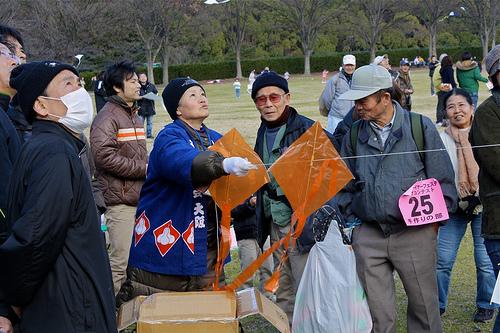Have they already had drinks?
Short answer required. No. What color is the kite?
Keep it brief. Orange. How many people are wearing hats?
Concise answer only. 8. What object is the kid throwing in the air?
Be succinct. Kite. What color are the bags?
Quick response, please. White. What number is here?
Quick response, please. 25. How many people are wearing surgical masks?
Concise answer only. 1. What is on the woman in blue's head?
Answer briefly. Hat. What is this man doing tricks on?
Answer briefly. Kite. Are all the people the same race?
Be succinct. Yes. 